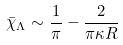<formula> <loc_0><loc_0><loc_500><loc_500>\bar { \chi } _ { \Lambda } \sim \frac { 1 } { \pi } - \frac { 2 } { \pi \kappa R }</formula> 